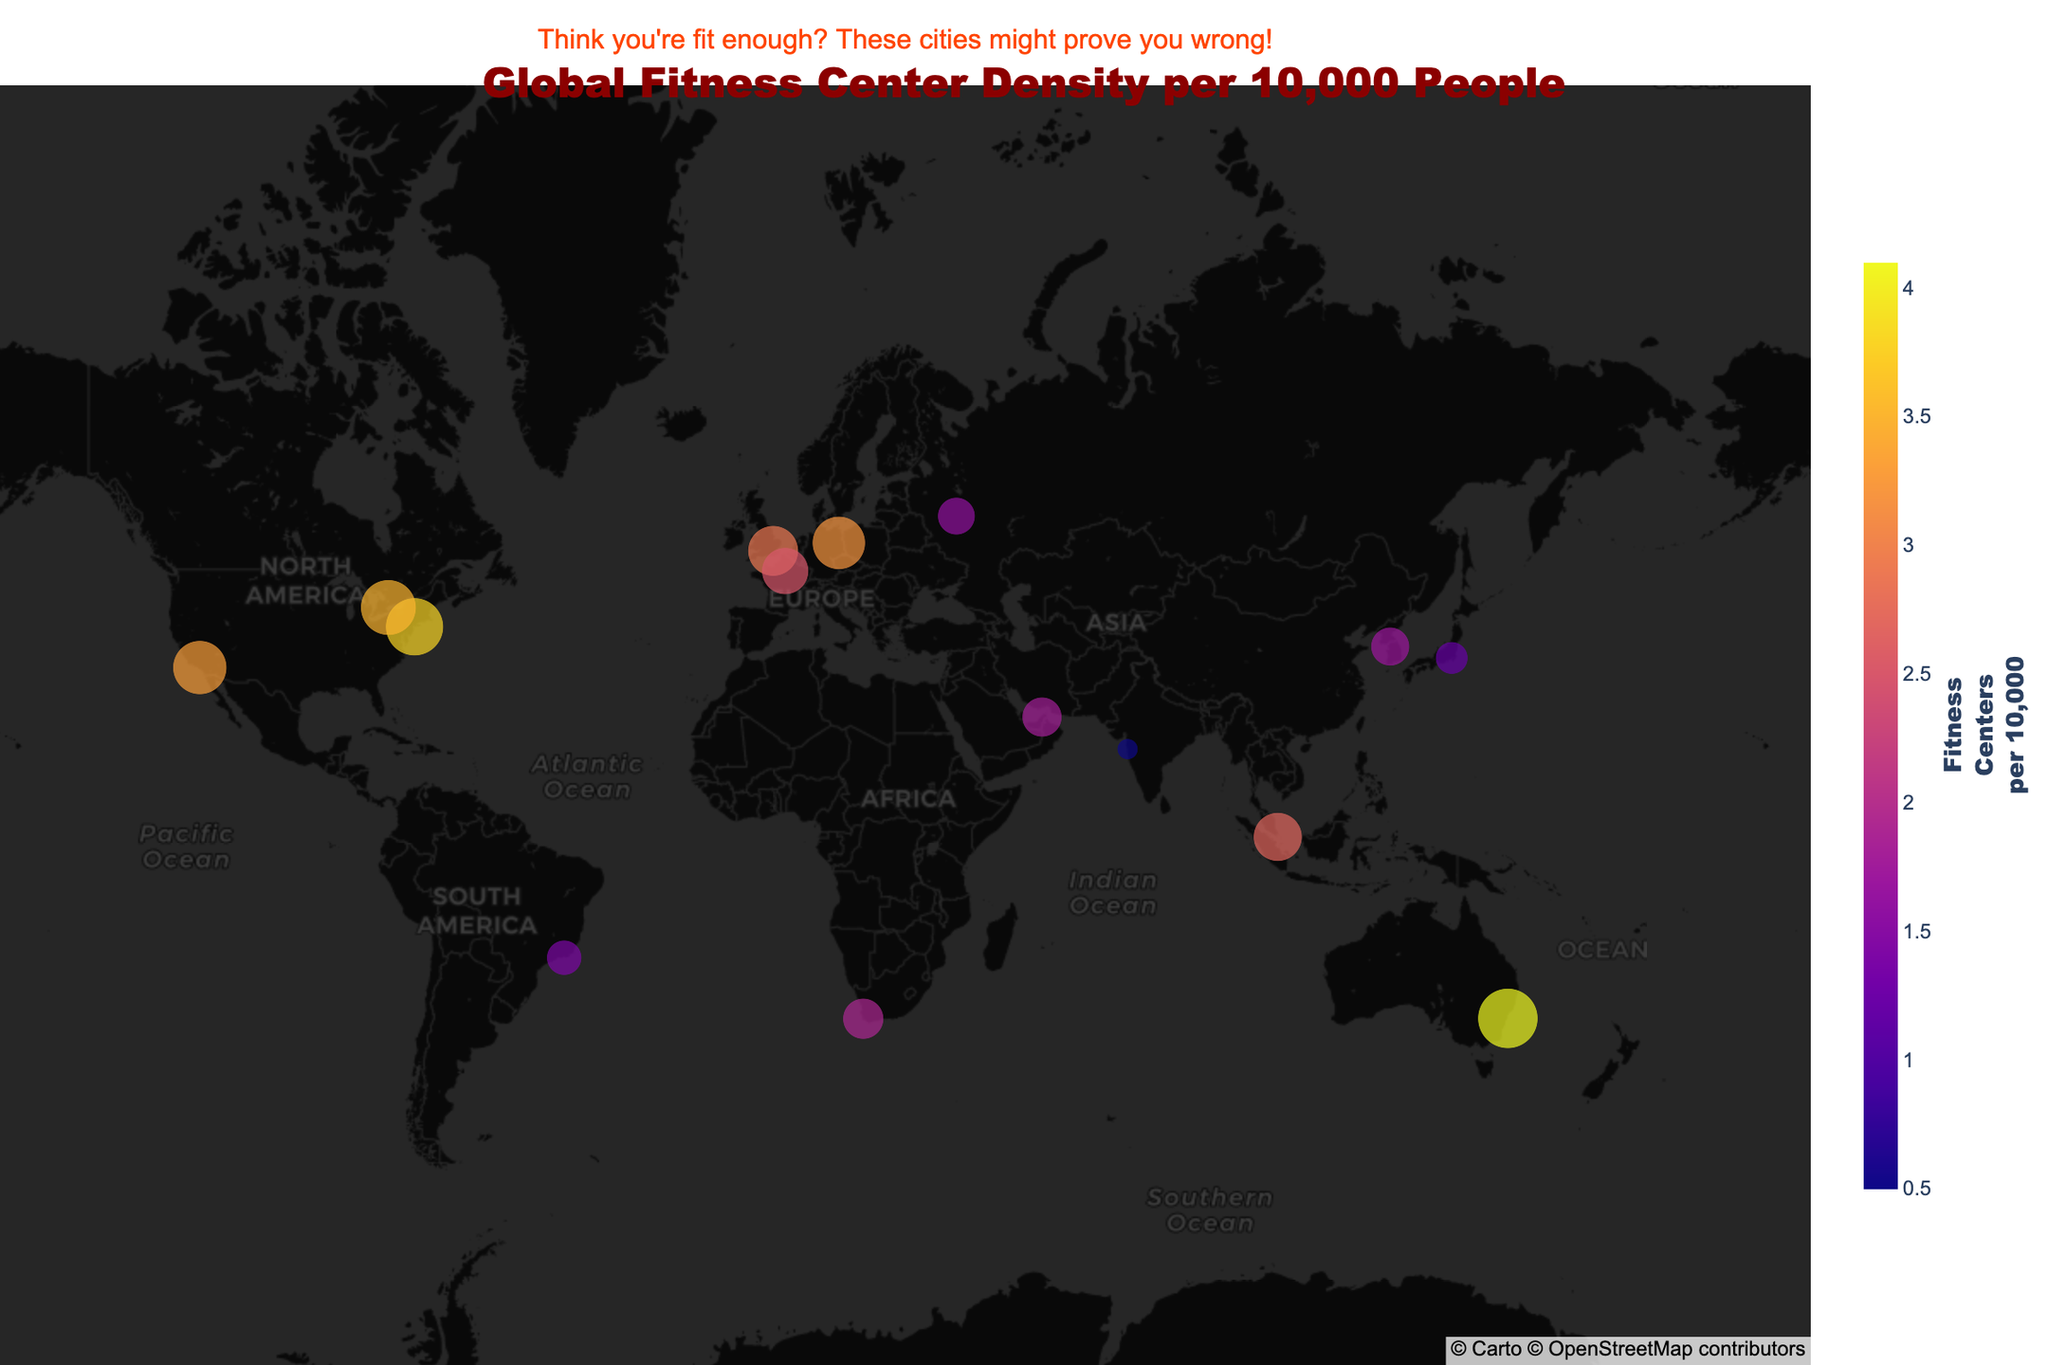How many cities have a fitness center density greater than 3 per 10,000 people? First, identify all the cities where the size of the bubble indicates a density greater than 3 per 10,000 people. We can see that New York City, Sydney, Berlin, and Toronto have densities greater than 3. Thus, the number of such cities is four.
Answer: 4 Which city has the highest fitness center density per 10,000 people? Look for the city with the largest bubble and the highest color intensity. Sydney has the highest fitness center density per 10,000 people at 4.1.
Answer: Sydney What is the average fitness center density per 10,000 people for cities in the USA? Identify the cities in the USA, which are New York City and Los Angeles, with densities of 3.8 and 3.3 respectively. Sum these densities (3.8 + 3.3 = 7.1) and divide by the number of cities (7.1 / 2 = 3.55). Thus, the average fitness center density for USA cities is 3.55.
Answer: 3.55 Which city has the lowest fitness center density per 10,000 people? Find the city with the smallest bubble and lowest color intensity. Mumbai has the lowest density at 0.5 fitness centers per 10,000 people.
Answer: Mumbai Compare fitness center densities between Tokyo and Rio de Janeiro. Which city has a higher density and by how much? Identify the densities for Tokyo (1.2) and Rio de Janeiro (1.4). Rio de Janeiro has a higher density. The difference in density is 1.4 - 1.2 = 0.2. So, Rio de Janeiro has a higher density by 0.2 fitness centers per 10,000 people.
Answer: Rio de Janeiro, 0.2 Are there more cities with a fitness center density above or below 2 per 10,000 people? Count the cities with densities above 2 (New York City, London, Paris, Sydney, Berlin, Singapore, Toronto, Los Angeles) which is 8, and below 2 (Tokyo, Dubai, Mumbai, Rio de Janeiro, Cape Town, Moscow, Seoul) which is 7. Thus, there are more cities with a density above 2.
Answer: Above What is the median fitness center density value for all cities? List the densities in ascending order: 0.5, 1.2, 1.4, 1.6, 1.7, 1.8, 1.9, 2.5, 2.7, 2.9, 3.2, 3.3, 3.5, 3.8, 4.1. The median is the middle value, which is 2.5.
Answer: 2.5 Which city is located at the northernmost point on the map? Identify the city with the highest latitude. Moscow, with a latitude of 55.7558, is the northernmost city.
Answer: Moscow 